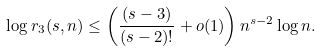Convert formula to latex. <formula><loc_0><loc_0><loc_500><loc_500>\log r _ { 3 } ( s , n ) \leq \left ( \frac { ( s - 3 ) } { ( s - 2 ) ! } + o ( 1 ) \right ) n ^ { s - 2 } \log n .</formula> 